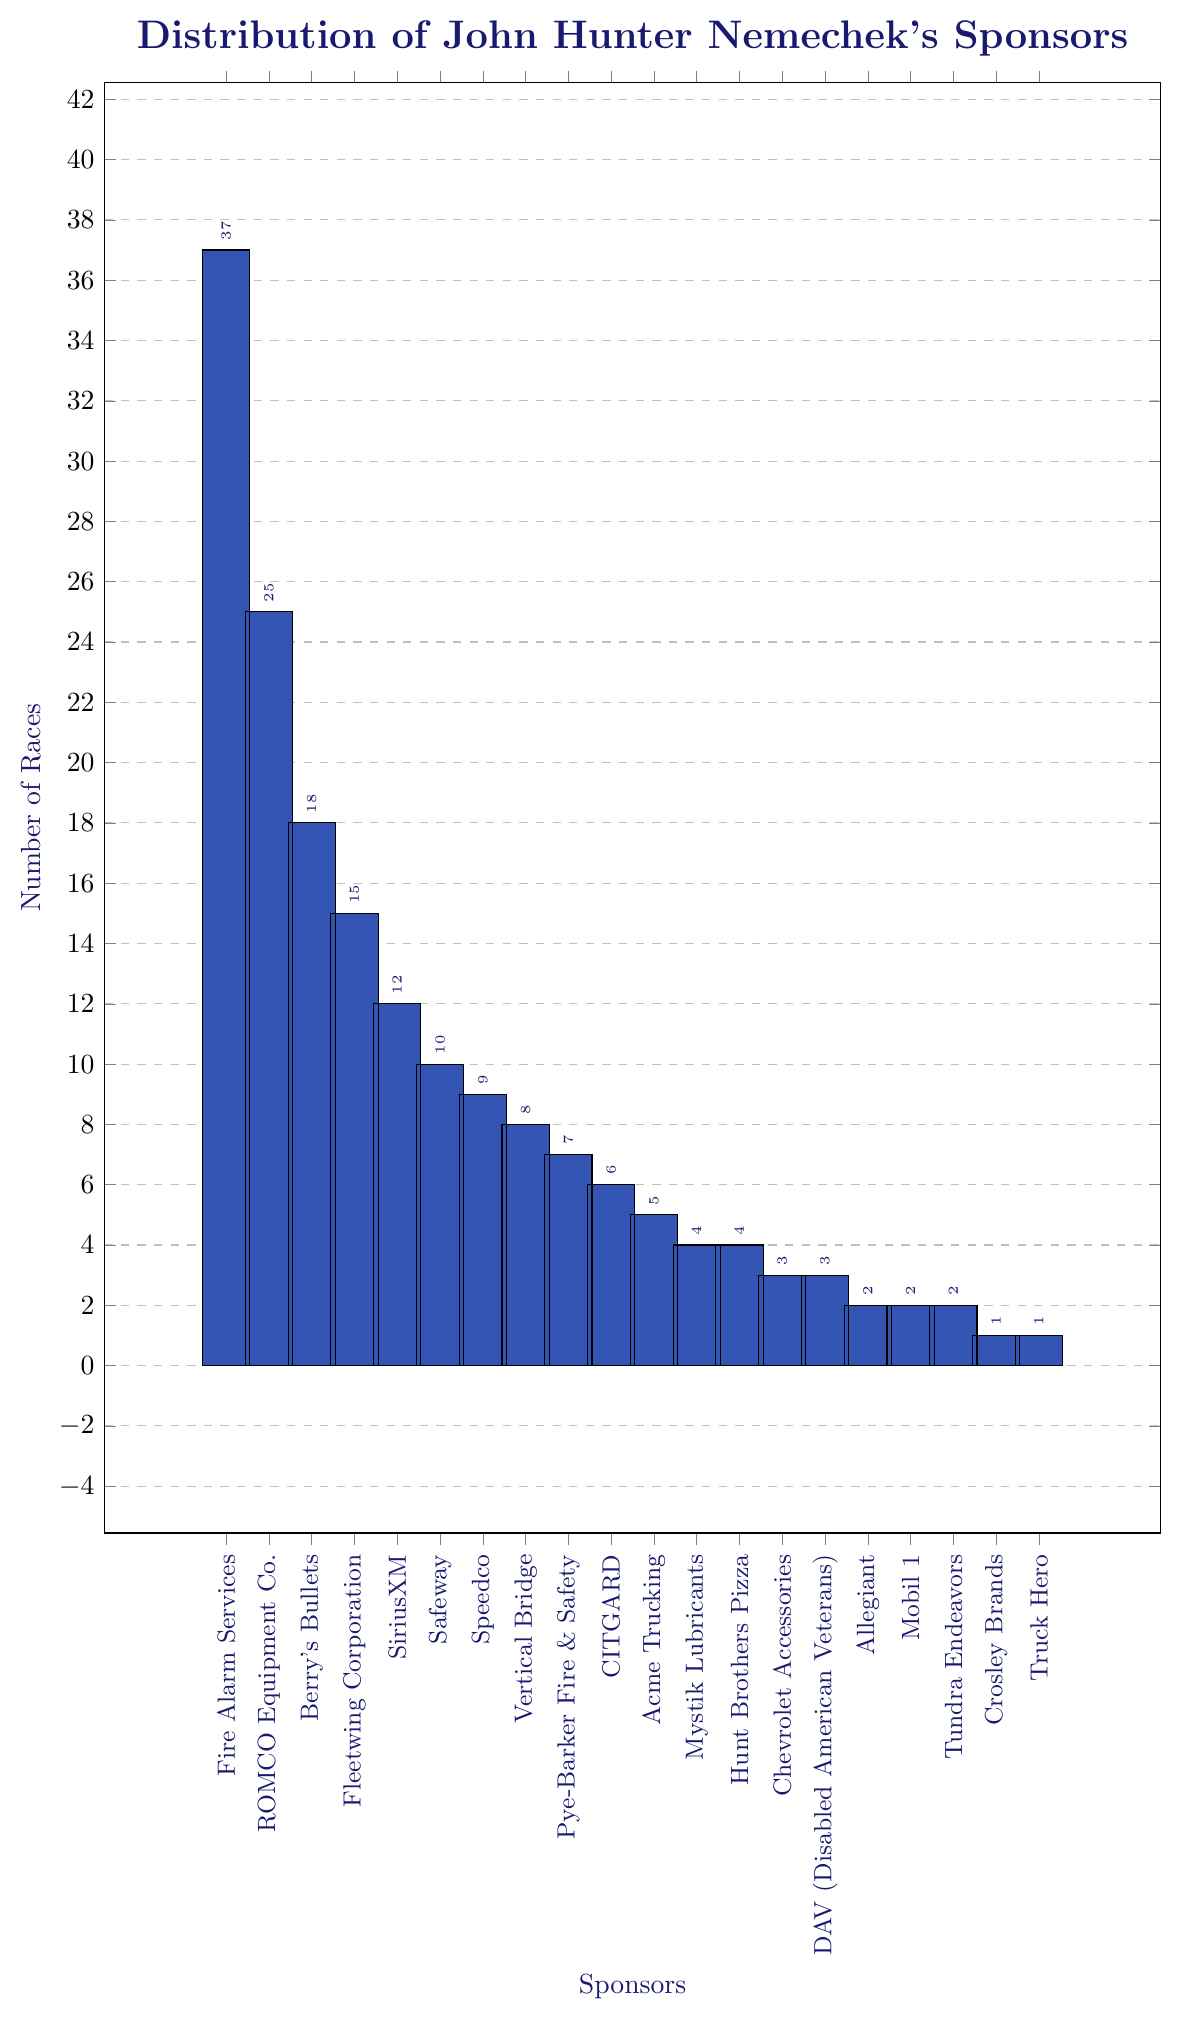Which sponsor has the highest number of races? The highest bar represents the sponsor with the highest number of races. Fire Alarm Services has the tallest bar with 37 races.
Answer: Fire Alarm Services Which sponsors have participated in exactly 4 races? Look for bars with a height of 4 on the y-axis and check the corresponding sponsor names. These sponsors are Mystik Lubricants and Hunt Brothers Pizza.
Answer: Mystik Lubricants and Hunt Brothers Pizza What is the total number of races for sponsors that have 7 or fewer races? Add up the number of races for each sponsor with 7 or fewer races: 
Pye-Barker Fire & Safety: 7, CITGARD: 6, Acme Trucking: 5, Mystik Lubricants: 4, Hunt Brothers Pizza: 4, Chevrolet Accessories: 3, DAV (Disabled American Veterans): 3, Allegiant: 2, Mobil 1: 2, Tundra Endeavors: 2, Crosley Brands: 1, Truck Hero: 1. 
So, the total is 7 + 6 + 5 + 4 + 4 + 3 + 3 + 2 + 2 + 2 + 1 + 1 = 40.
Answer: 40 How many more races has Fire Alarm Services participated in compared to ROMCO Equipment Co.? Subtract the number of races for ROMCO Equipment Co. from that of Fire Alarm Services: 37 - 25 = 12.
Answer: 12 Is the number of races for Speedco greater than for Vertical Bridge? Compare the heights of the bars for Speedco and Vertical Bridge. Speedco has 9 races while Vertical Bridge has 8. 9 is greater than 8.
Answer: Yes Which sponsors have participated in fewer than 3 races? Find the bars with heights less than 3 and look at the corresponding sponsor names. These sponsors are Allegiant, Mobil 1, Tundra Endeavors, Crosley Brands, and Truck Hero.
Answer: Allegiant, Mobil 1, Tundra Endeavors, Crosley Brands, and Truck Hero What is the median number of races for all sponsors? List all the race counts in increasing order: 1, 1, 2, 2, 2, 3, 3, 4, 4, 5, 6, 7, 8, 9, 10, 12, 15, 18, 25, 37. With 20 data points, the median is the average of the 10th and 11th values: (5 + 6) / 2 = 5.5.
Answer: 5.5 Which sponsor has the lowest number of races? The shortest bar indicates the sponsor with the lowest number of races. There are two sponsors with the shortest bars, Crosley Brands, and Truck Hero, each with 1 race.
Answer: Crosley Brands and Truck Hero How many sponsors have participated in more than 15 races? Count the bars that are higher than 15 on the y-axis and identify the corresponding sponsors. These sponsors are Fire Alarm Services, ROMCO Equipment Co., Berry's Bullets, and Fleetwing Corporation. There are 4 in total.
Answer: 4 Comparing the number of races between SiriusXM and Safeway, by how many races does SiriusXM lead? Subtract the number of races for Safeway from that of SiriusXM: 12 - 10 = 2.
Answer: 2 